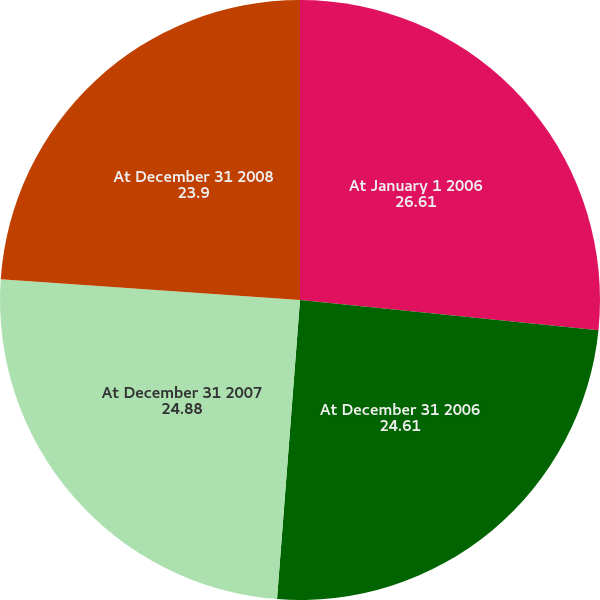<chart> <loc_0><loc_0><loc_500><loc_500><pie_chart><fcel>At January 1 2006<fcel>At December 31 2006<fcel>At December 31 2007<fcel>At December 31 2008<nl><fcel>26.61%<fcel>24.61%<fcel>24.88%<fcel>23.9%<nl></chart> 